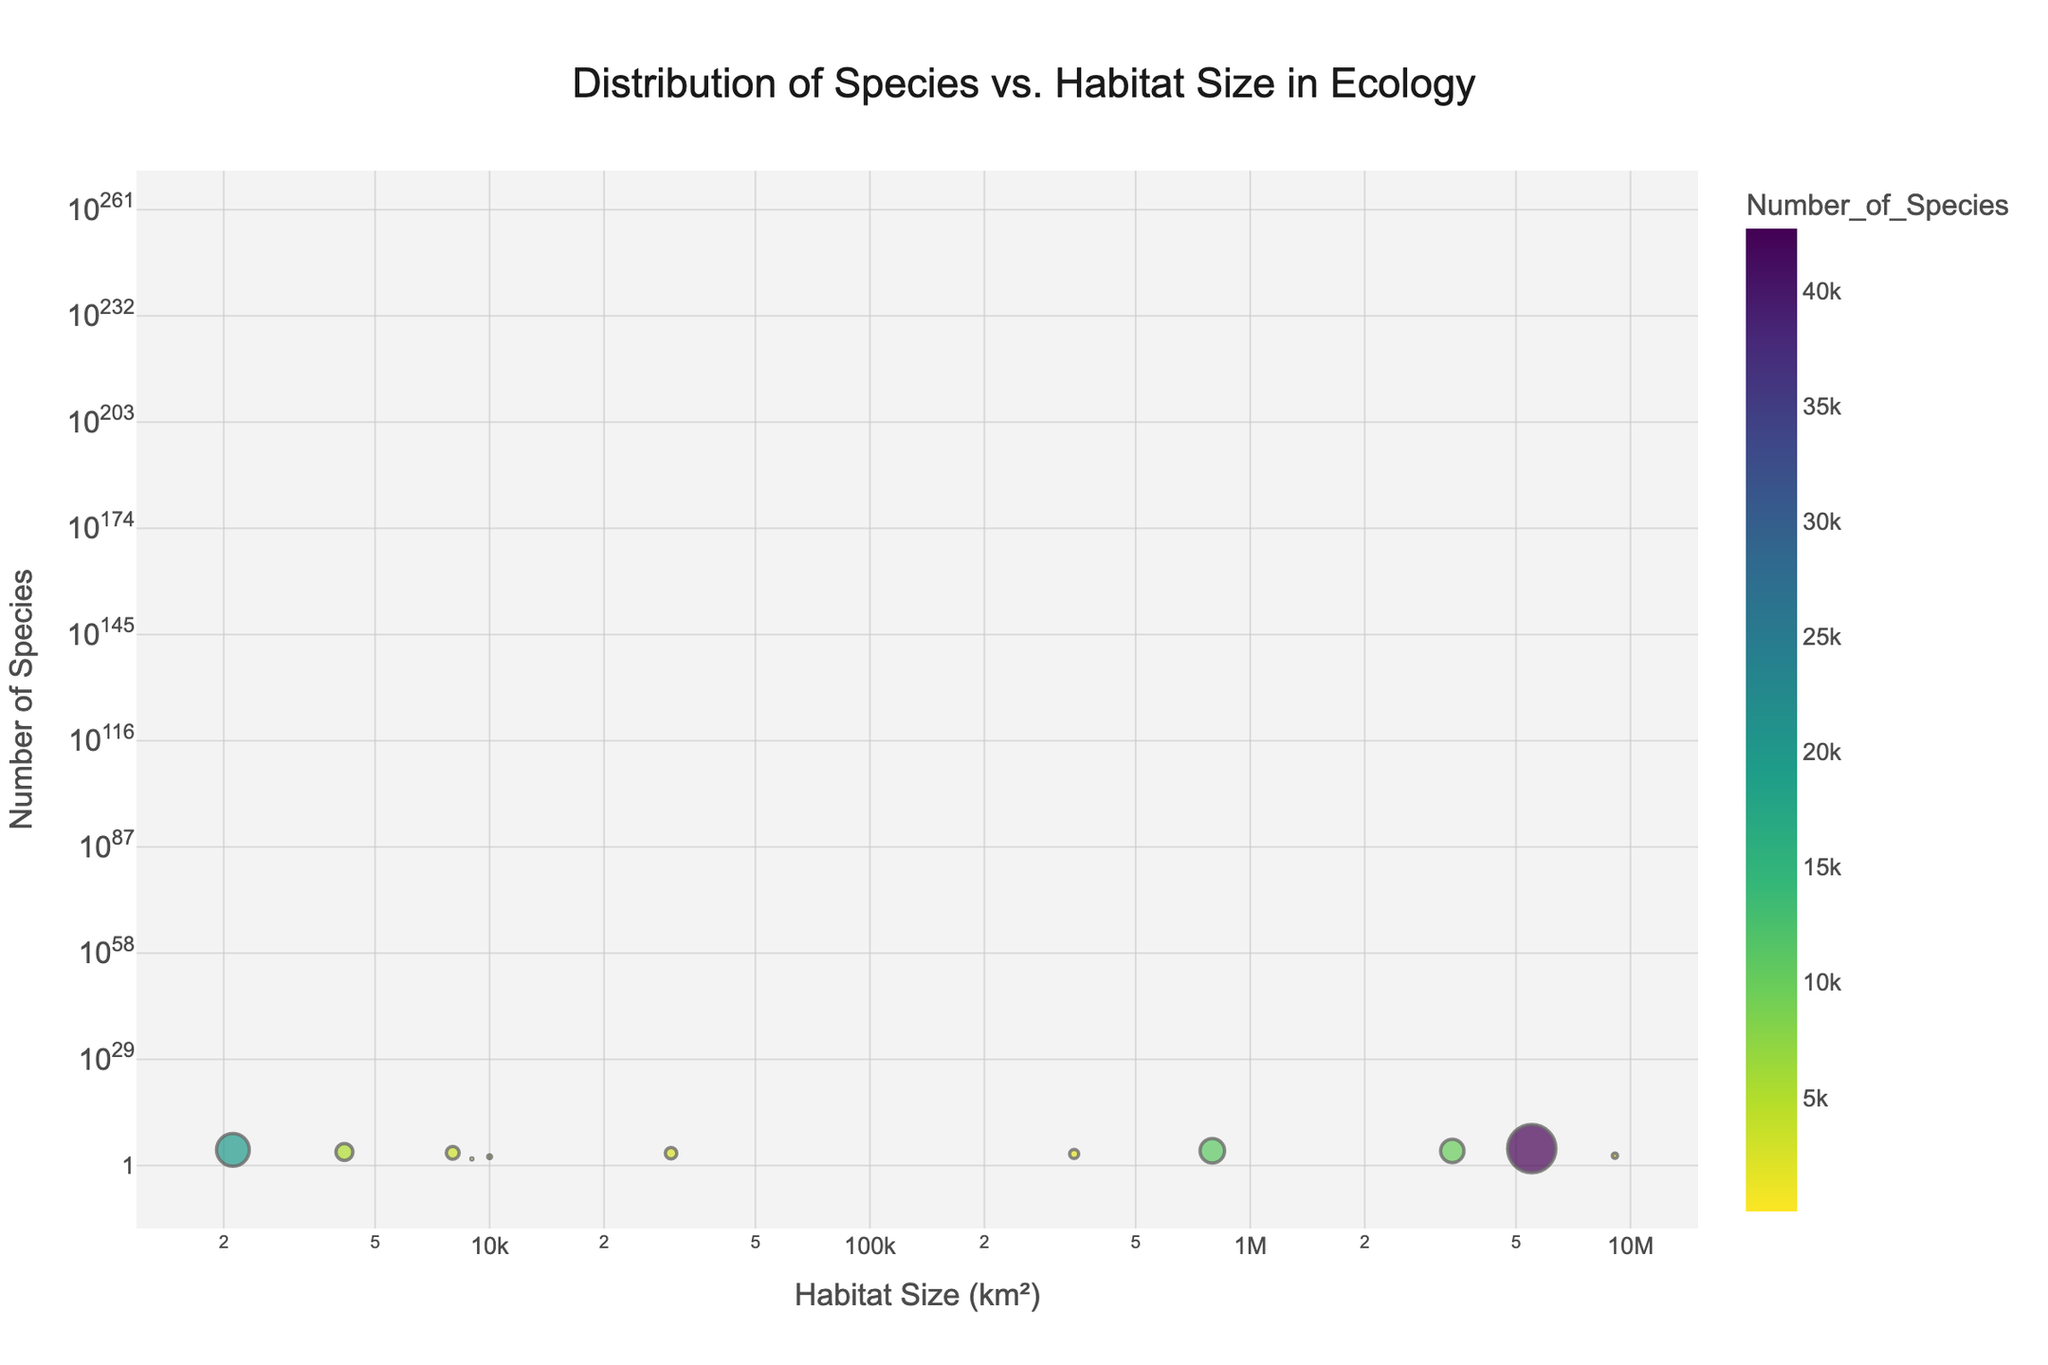what is the title of the figure? The title of the figure is typically found at the top and is intended to summarize what the plot is about. In this case, the title is given in the code.
Answer: Distribution of Species vs. Habitat Size in Ecology which axis represents habitat size? To determine the axis for habitat size, you should look for the axis labeled "Habitat Size (km²)." According to the code, this is the x-axis.
Answer: x-axis how is the number of species represented visually? The number of species is indicated on the y-axis and is also used to determine the color and size of the data points. Larger circles with brighter colors have more species.
Answer: y-axis, color, and size which data point represents the Amazon Rainforest? To identify the Amazon Rainforest data point, look for the annotation "Amazon Rainforest." It is located among the points with a larger habitat size and a high number of species.
Answer: Large habitat size and high number of species which habitat has the second largest number of species? The habitat with the second largest number of species can be found by identifying the second highest dot on the y-axis. According to the data, the Great Smoky Mountains has the second-largest number of species with 19,677.
Answer: Great Smoky Mountains which habitat has the smallest habitat size? To find the habitat with the smallest size, look for the point closest to the origin on the x-axis. According to the data, the Danube Delta has the smallest habitat size of 4152 km².
Answer: Danube Delta what is the difference in the number of species between the Great Barrier Reef and the Sundarbans? Great Barrier Reef has 1500 species, while Sundarbans has 260. The difference is calculated by subtracting the smaller number from the larger number (1500 - 260).
Answer: 1240 how does habitat size relate to the number of species? By examining the scatter plot, you can observe whether larger habitats tend to have more species or not. Generally, larger habitats have dots higher up on the y-axis, indicating more species. However, there are exceptions.
Answer: Generally positive correlation compare the number of species in western Tanzania to those in the Galápagos Islands Western Tanzania (Serengeti) has 2,390 species, whereas Galápagos Islands has 3,000 species. By comparing these numbers, the Galápagos has more species.
Answer: Galápagos Islands has more species what color is used to represent the highest number of species? Referring to the color scale (Viridis) used, the color representing the highest number of species (in this case, 42,700 species for Amazon Rainforest) is usually the brightest or warmest color in the scale.
Answer: Brightest color in Viridis scale 